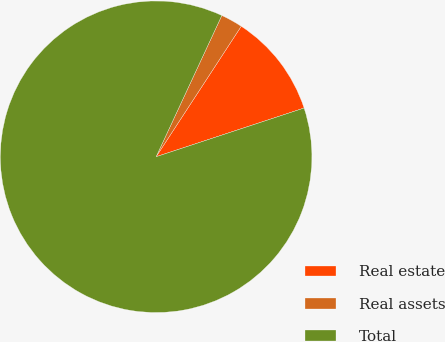<chart> <loc_0><loc_0><loc_500><loc_500><pie_chart><fcel>Real estate<fcel>Real assets<fcel>Total<nl><fcel>10.74%<fcel>2.27%<fcel>86.99%<nl></chart> 